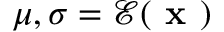<formula> <loc_0><loc_0><loc_500><loc_500>\mu , \sigma = \mathcal { E } ( x )</formula> 